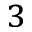<formula> <loc_0><loc_0><loc_500><loc_500>^ { 3 }</formula> 